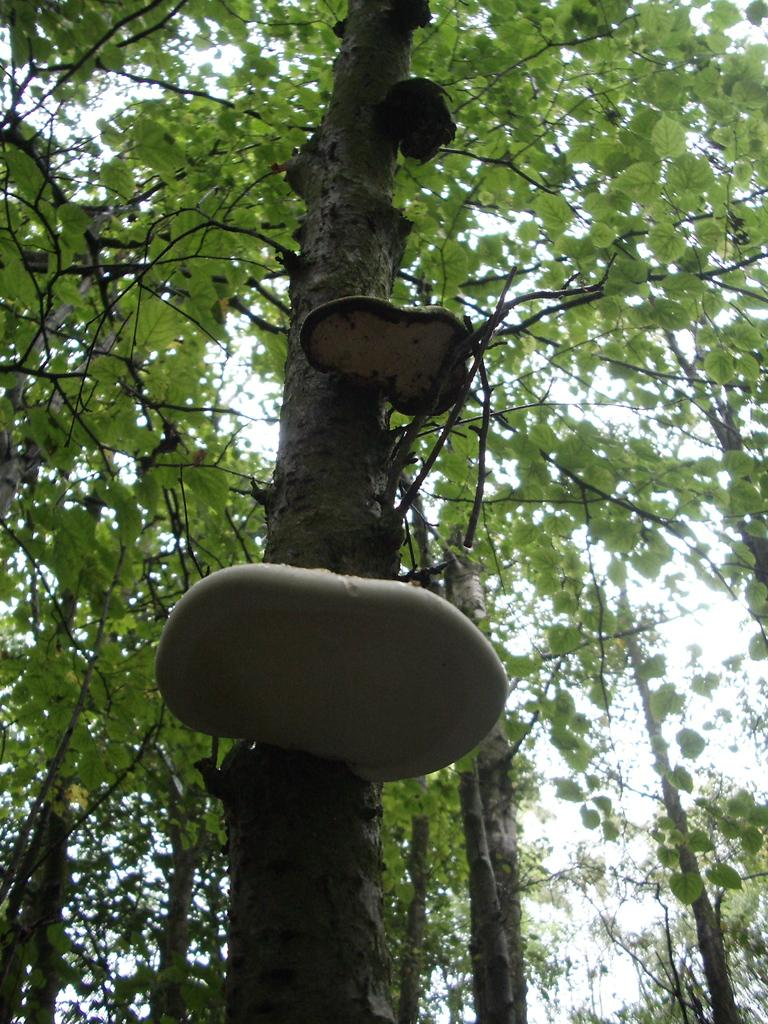What type of vegetation can be seen in the image? There are trees in the image. What part of the natural environment is visible in the image? The sky is visible in the image. Can you see the ocean in the image? No, there is no ocean visible in the image; only trees and the sky are present. 